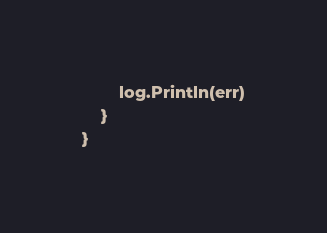<code> <loc_0><loc_0><loc_500><loc_500><_Go_>		log.Println(err)
	}
}
</code> 